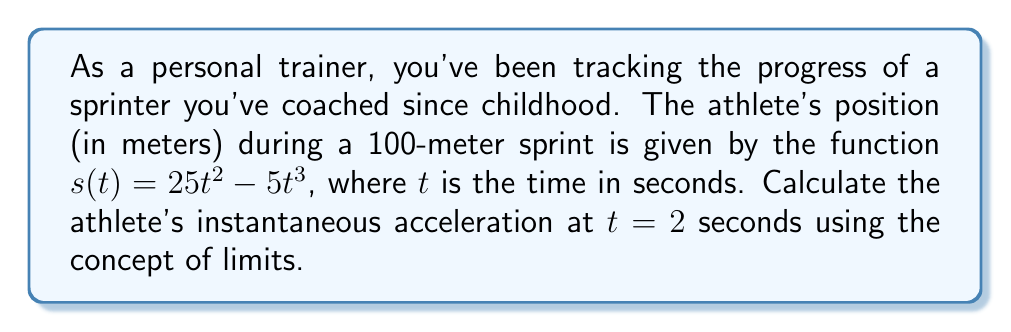Provide a solution to this math problem. To find the instantaneous acceleration at $t = 2$ seconds, we need to calculate the second derivative of the position function $s(t)$ and evaluate it at $t = 2$. Let's break this down step-by-step:

1) First, we need to find the velocity function $v(t)$, which is the first derivative of $s(t)$:

   $$v(t) = s'(t) = \lim_{h \to 0} \frac{s(t+h) - s(t)}{h}$$
   
   $$= \lim_{h \to 0} \frac{25(t+h)^2 - 5(t+h)^3 - (25t^2 - 5t^3)}{h}$$
   
   Expanding and simplifying:
   
   $$= \lim_{h \to 0} \frac{50th + 25h^2 - 15t^2h - 15th^2 - 5h^3}{h}$$
   
   $$= \lim_{h \to 0} (50t + 25h - 15t^2 - 15th - 5h^2)$$
   
   $$= 50t - 15t^2$$

2) Now we need to find the acceleration function $a(t)$, which is the derivative of $v(t)$:

   $$a(t) = v'(t) = \lim_{h \to 0} \frac{v(t+h) - v(t)}{h}$$
   
   $$= \lim_{h \to 0} \frac{50(t+h) - 15(t+h)^2 - (50t - 15t^2)}{h}$$
   
   $$= \lim_{h \to 0} \frac{50h - 30th - 15h^2}{h}$$
   
   $$= \lim_{h \to 0} (50 - 30t - 15h)$$
   
   $$= 50 - 30t$$

3) Finally, we can calculate the instantaneous acceleration at $t = 2$ seconds:

   $$a(2) = 50 - 30(2) = 50 - 60 = -10$$

The negative acceleration indicates that the athlete is decelerating at this point in the sprint.
Answer: The instantaneous acceleration of the athlete at $t = 2$ seconds is $-10$ m/s². 